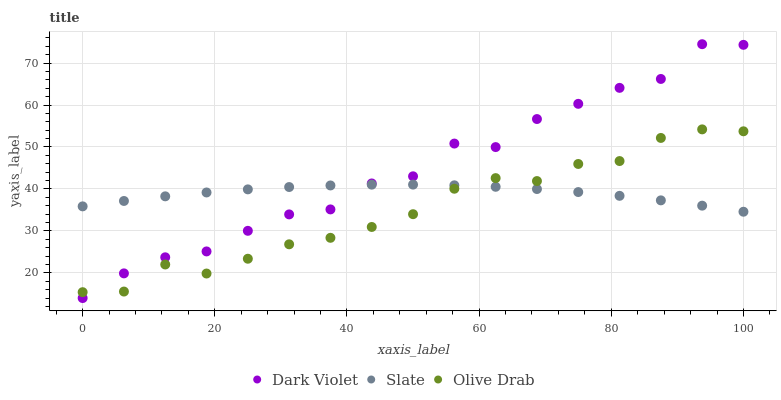Does Olive Drab have the minimum area under the curve?
Answer yes or no. Yes. Does Dark Violet have the maximum area under the curve?
Answer yes or no. Yes. Does Dark Violet have the minimum area under the curve?
Answer yes or no. No. Does Olive Drab have the maximum area under the curve?
Answer yes or no. No. Is Slate the smoothest?
Answer yes or no. Yes. Is Dark Violet the roughest?
Answer yes or no. Yes. Is Olive Drab the smoothest?
Answer yes or no. No. Is Olive Drab the roughest?
Answer yes or no. No. Does Dark Violet have the lowest value?
Answer yes or no. Yes. Does Olive Drab have the lowest value?
Answer yes or no. No. Does Dark Violet have the highest value?
Answer yes or no. Yes. Does Olive Drab have the highest value?
Answer yes or no. No. Does Slate intersect Dark Violet?
Answer yes or no. Yes. Is Slate less than Dark Violet?
Answer yes or no. No. Is Slate greater than Dark Violet?
Answer yes or no. No. 